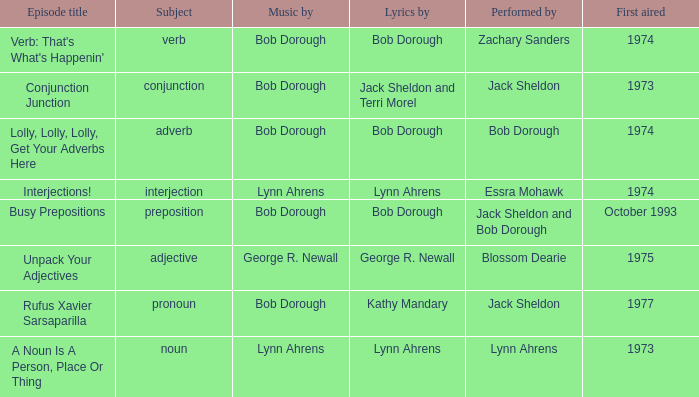When zachary sanders is the performer how many people is the music by? 1.0. 